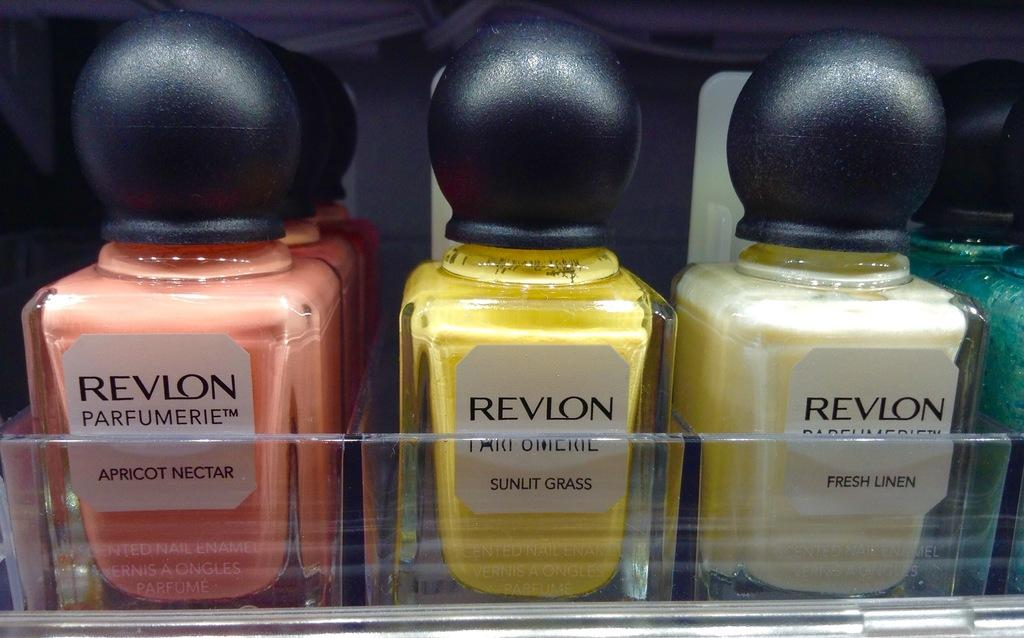<image>
Summarize the visual content of the image. Multiple bottles of Revlon nail polish sit in their display. 